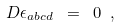<formula> <loc_0><loc_0><loc_500><loc_500>D \epsilon _ { a b c d } \ = \ 0 \ ,</formula> 